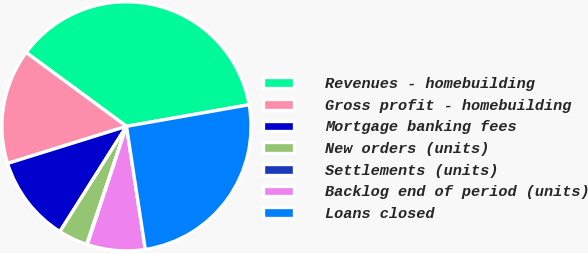Convert chart to OTSL. <chart><loc_0><loc_0><loc_500><loc_500><pie_chart><fcel>Revenues - homebuilding<fcel>Gross profit - homebuilding<fcel>Mortgage banking fees<fcel>New orders (units)<fcel>Settlements (units)<fcel>Backlog end of period (units)<fcel>Loans closed<nl><fcel>37.13%<fcel>14.91%<fcel>11.21%<fcel>3.8%<fcel>0.09%<fcel>7.5%<fcel>25.35%<nl></chart> 